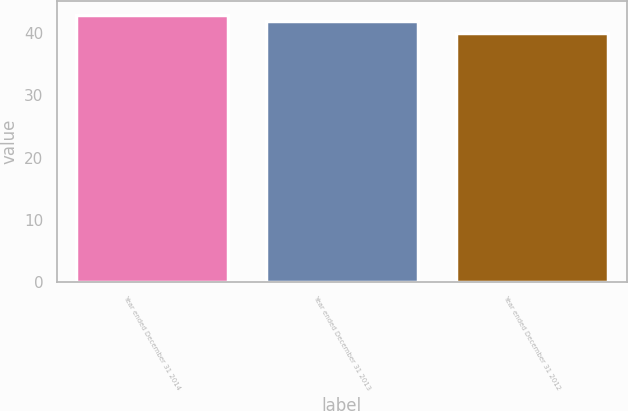Convert chart. <chart><loc_0><loc_0><loc_500><loc_500><bar_chart><fcel>Year ended December 31 2014<fcel>Year ended December 31 2013<fcel>Year ended December 31 2012<nl><fcel>43<fcel>42<fcel>40<nl></chart> 